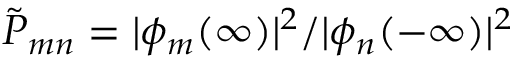Convert formula to latex. <formula><loc_0><loc_0><loc_500><loc_500>{ \tilde { P } } _ { m n } = | \phi _ { m } ( \infty ) | ^ { 2 } / | \phi _ { n } ( - \infty ) | ^ { 2 }</formula> 